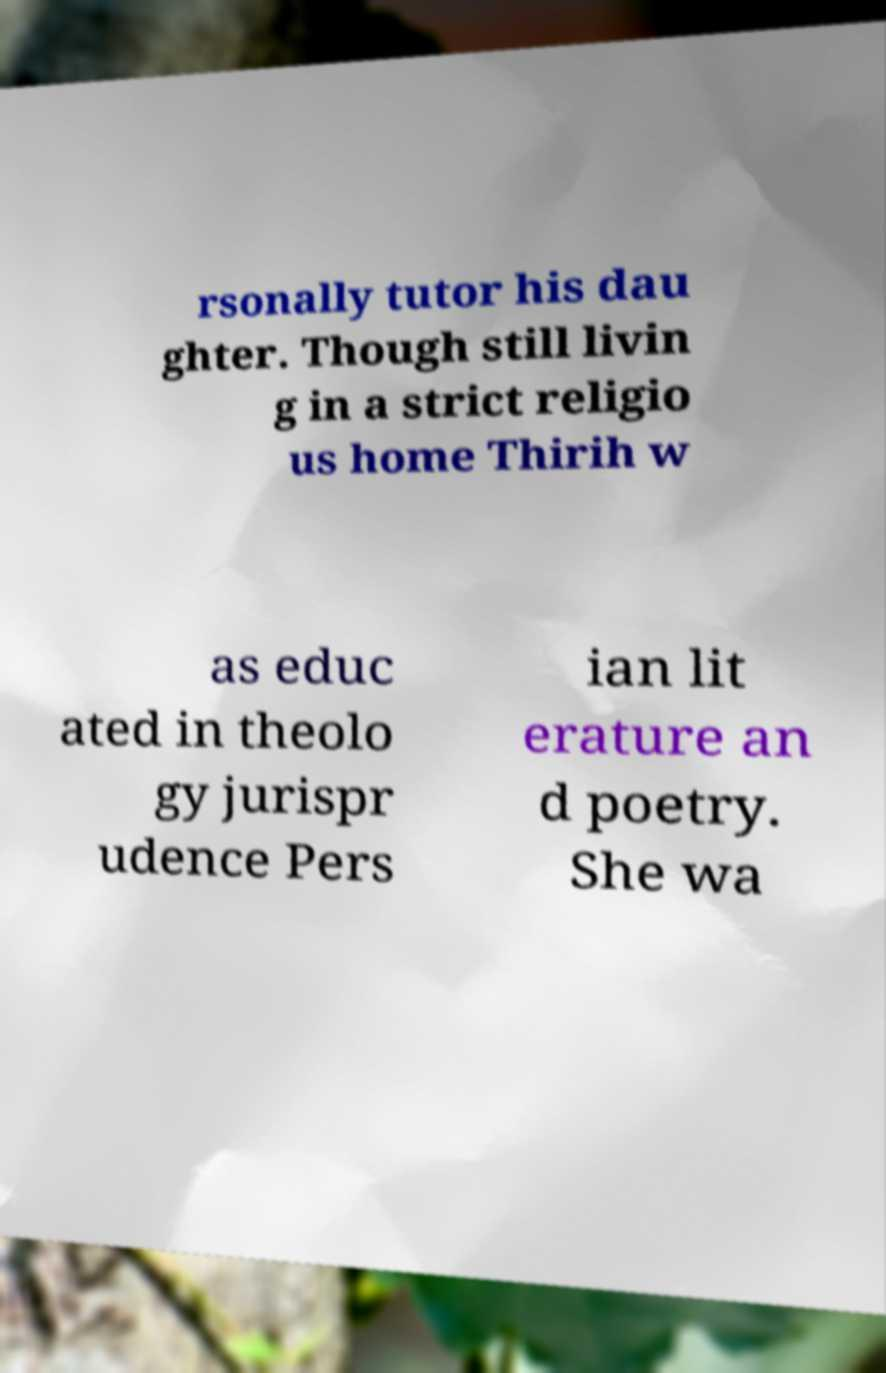Can you read and provide the text displayed in the image?This photo seems to have some interesting text. Can you extract and type it out for me? rsonally tutor his dau ghter. Though still livin g in a strict religio us home Thirih w as educ ated in theolo gy jurispr udence Pers ian lit erature an d poetry. She wa 